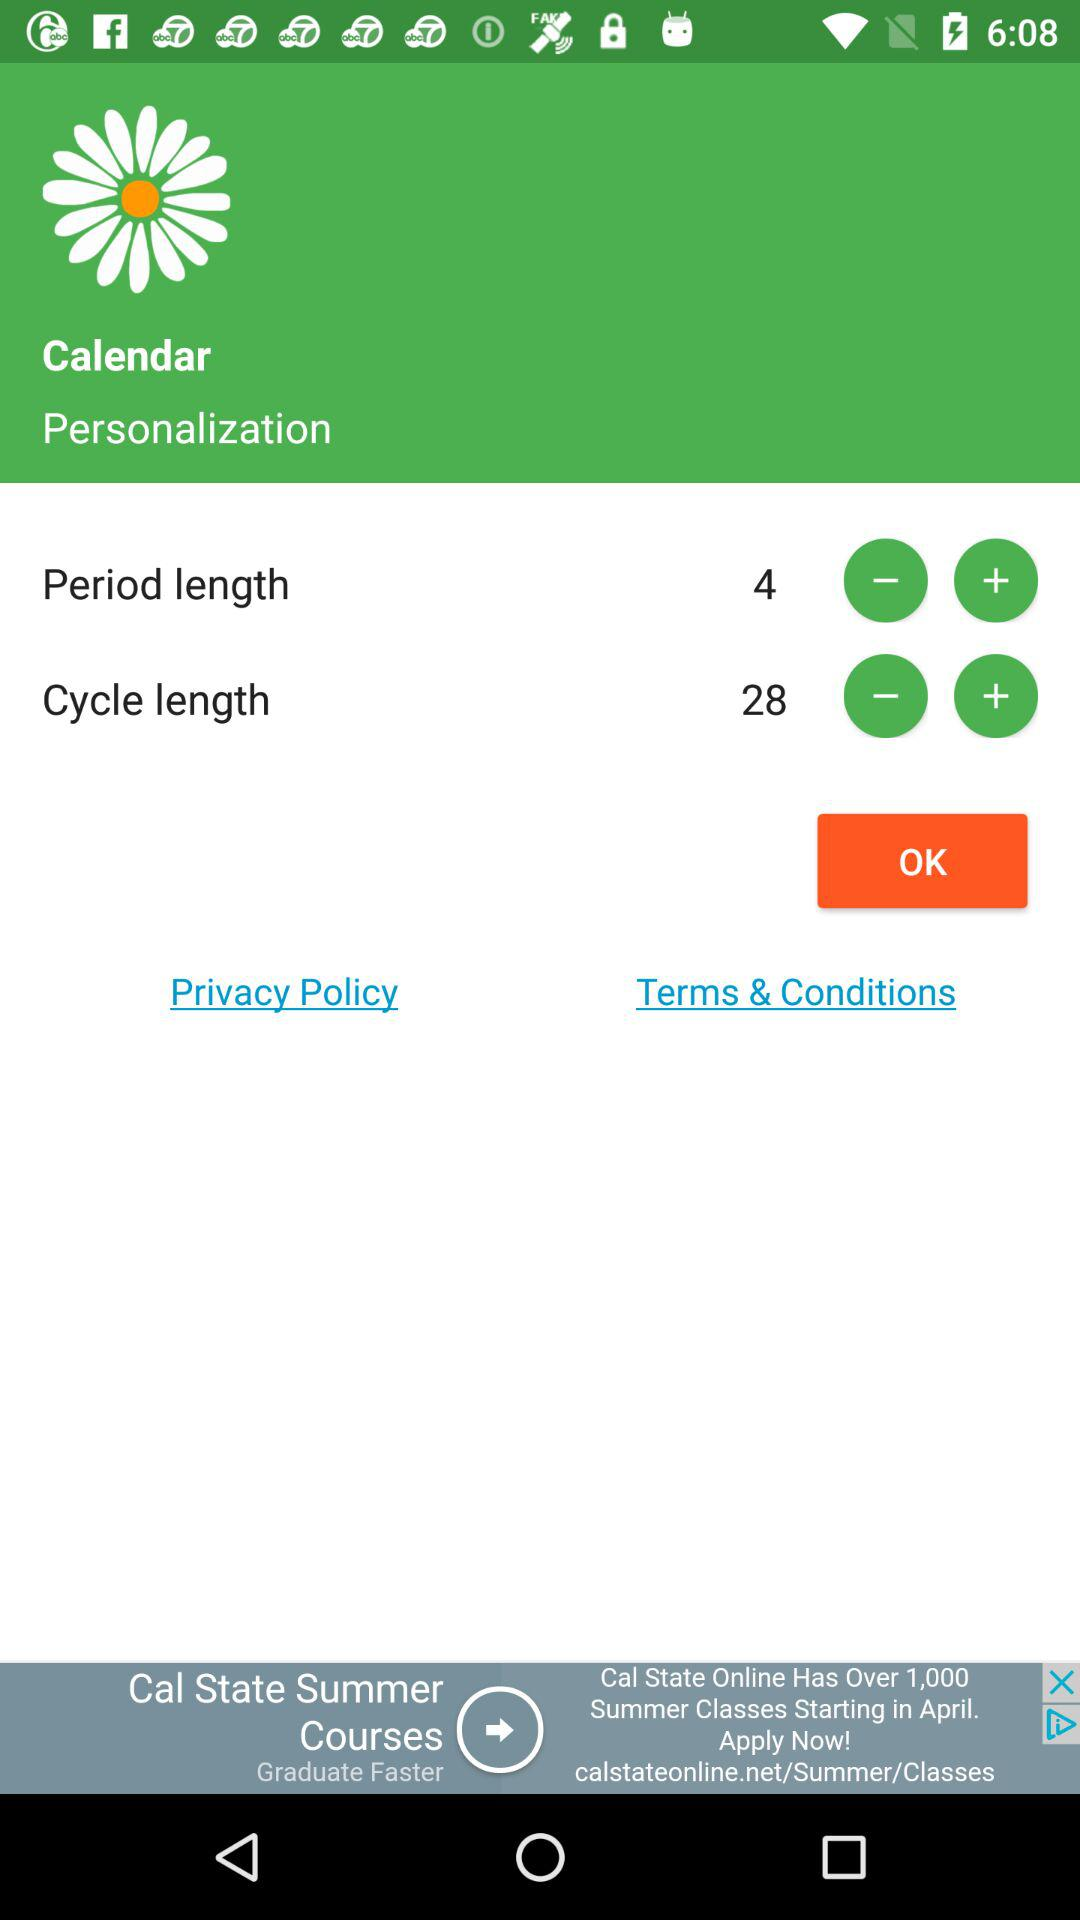What is the period length? The period length is 4. 